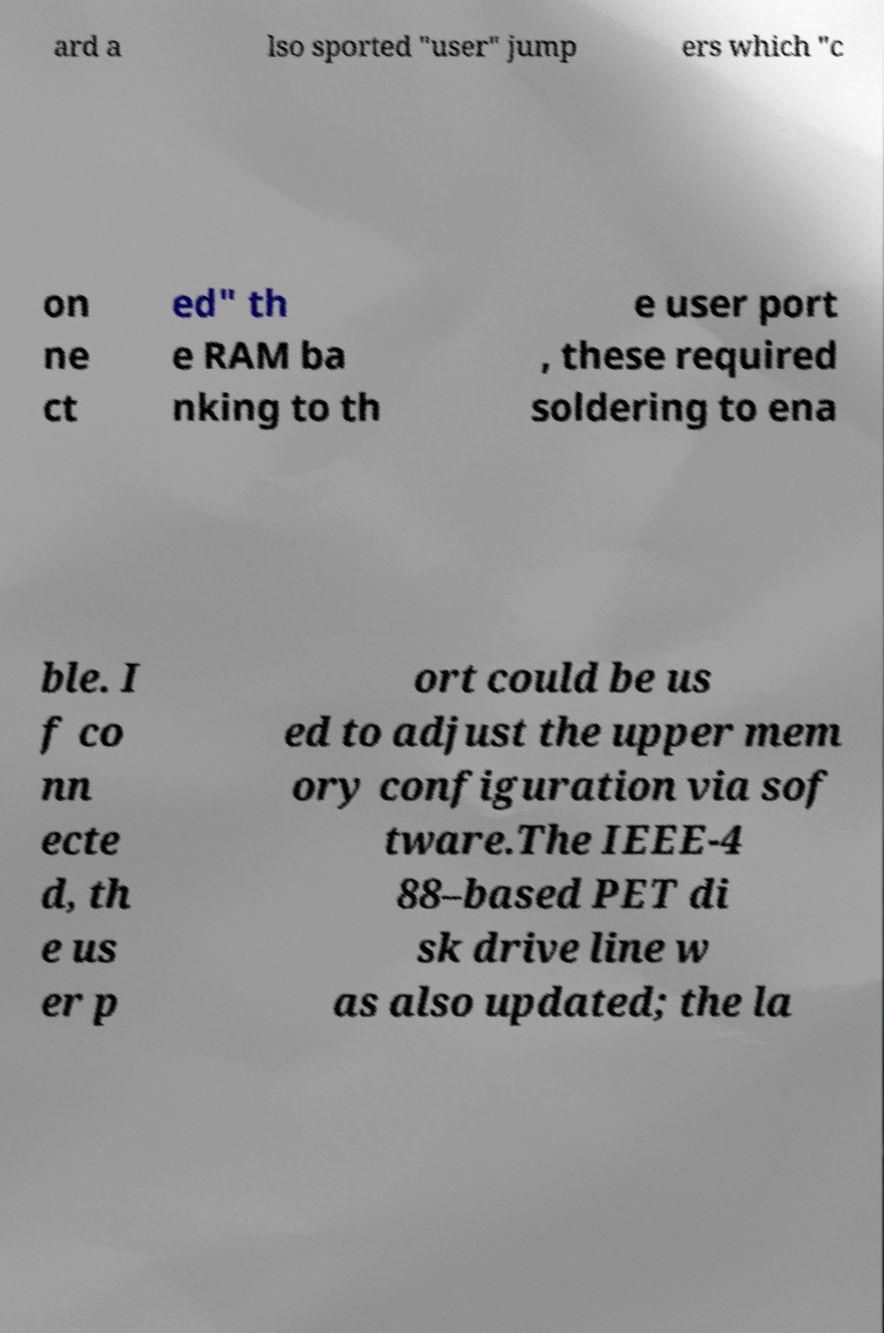For documentation purposes, I need the text within this image transcribed. Could you provide that? ard a lso sported "user" jump ers which "c on ne ct ed" th e RAM ba nking to th e user port , these required soldering to ena ble. I f co nn ecte d, th e us er p ort could be us ed to adjust the upper mem ory configuration via sof tware.The IEEE-4 88–based PET di sk drive line w as also updated; the la 